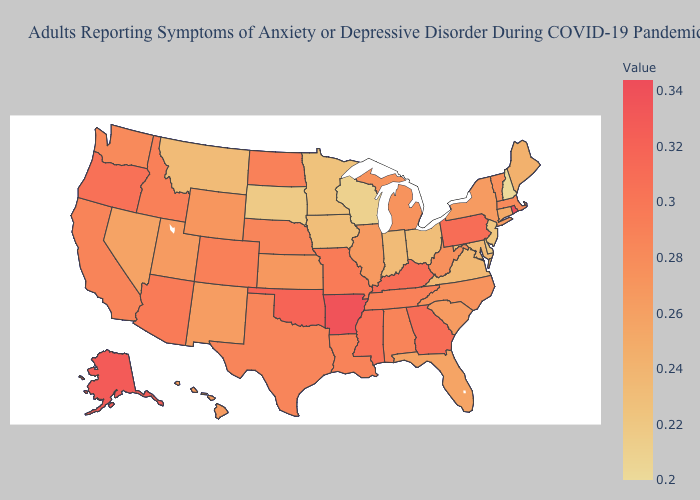Does Delaware have the lowest value in the South?
Short answer required. Yes. Which states hav the highest value in the South?
Concise answer only. Arkansas. Does Utah have the highest value in the USA?
Answer briefly. No. Does New Hampshire have the lowest value in the USA?
Quick response, please. Yes. Which states have the lowest value in the West?
Write a very short answer. Montana. 